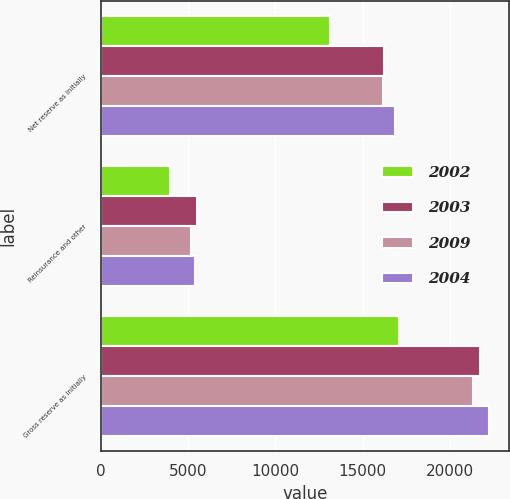<chart> <loc_0><loc_0><loc_500><loc_500><stacked_bar_chart><ecel><fcel>Net reserve as initially<fcel>Reinsurance and other<fcel>Gross reserve as initially<nl><fcel>2002<fcel>13141<fcel>3950<fcel>17091<nl><fcel>2003<fcel>16218<fcel>5497<fcel>21715<nl><fcel>2009<fcel>16191<fcel>5138<fcel>21329<nl><fcel>2004<fcel>16863<fcel>5403<fcel>22266<nl></chart> 